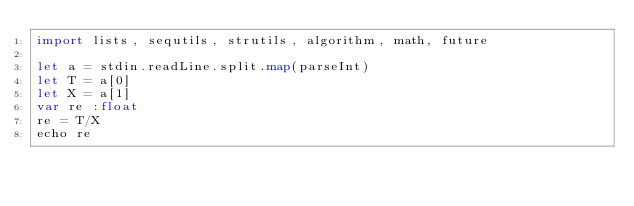<code> <loc_0><loc_0><loc_500><loc_500><_Nim_>import lists, sequtils, strutils, algorithm, math, future

let a = stdin.readLine.split.map(parseInt)
let T = a[0]
let X = a[1]
var re :float
re = T/X
echo re</code> 